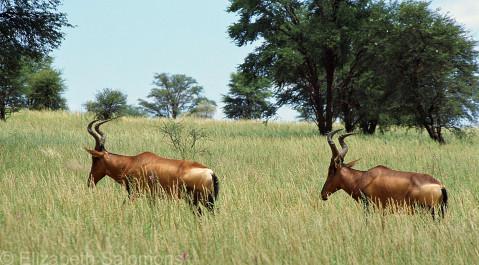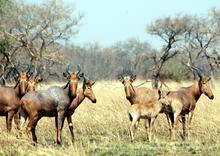The first image is the image on the left, the second image is the image on the right. Assess this claim about the two images: "One of the images has exactly two animals in it.". Correct or not? Answer yes or no. Yes. The first image is the image on the left, the second image is the image on the right. Considering the images on both sides, is "One of the images contains no more than four antelopes" valid? Answer yes or no. Yes. 